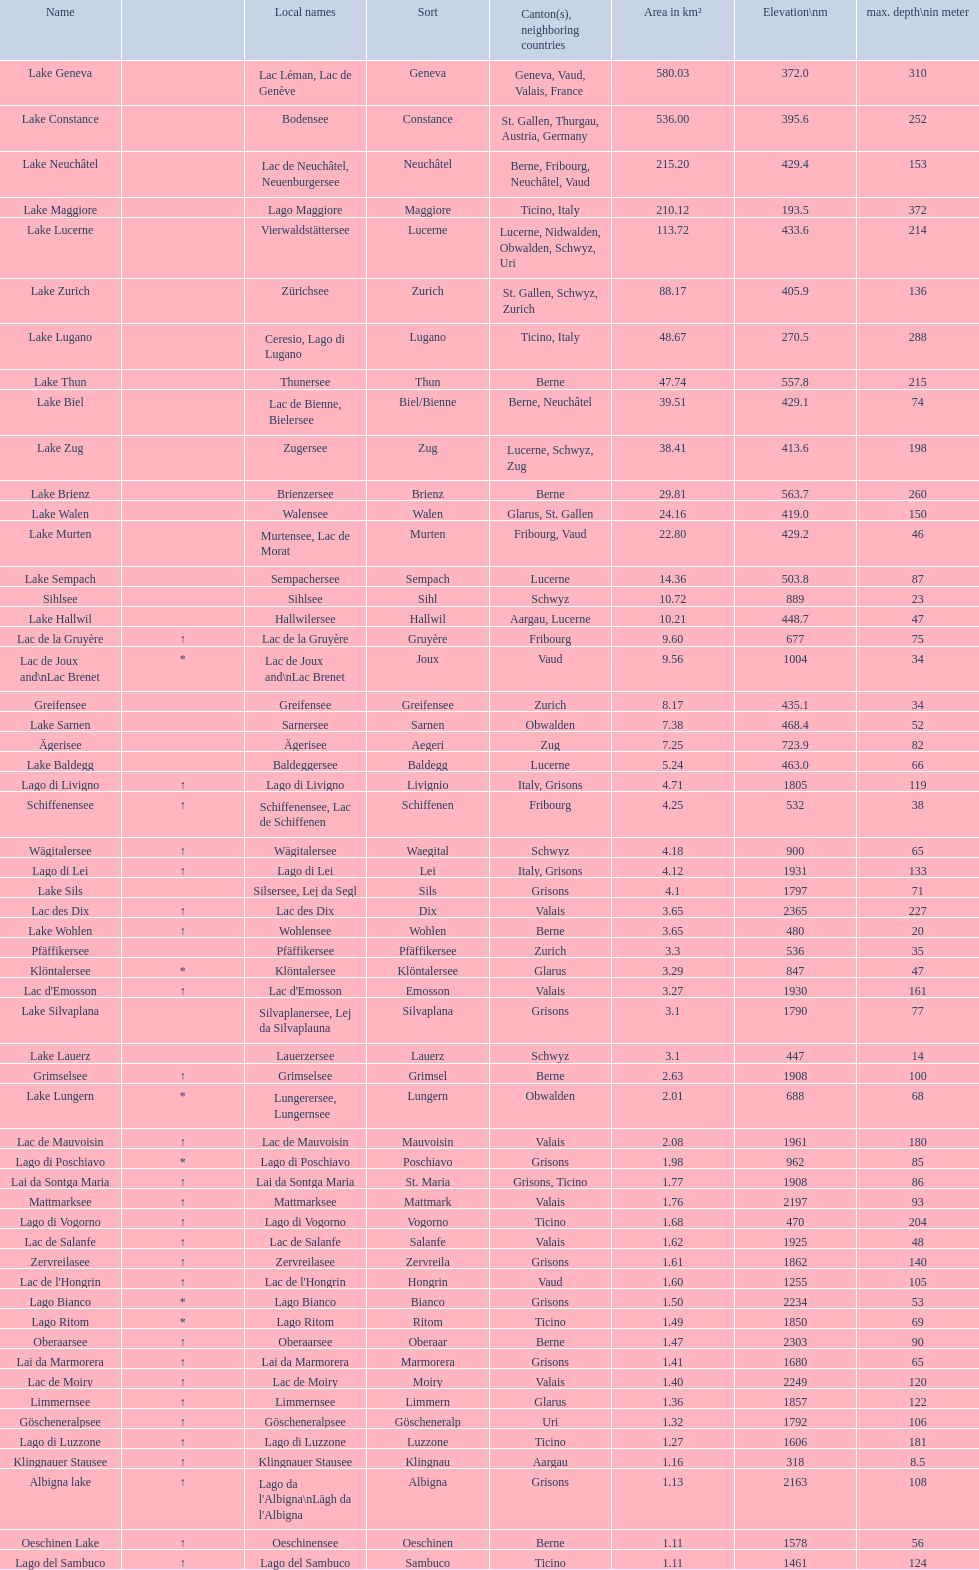Which lake possesses a minimum of 580 square kilometers in area? Lake Geneva. 